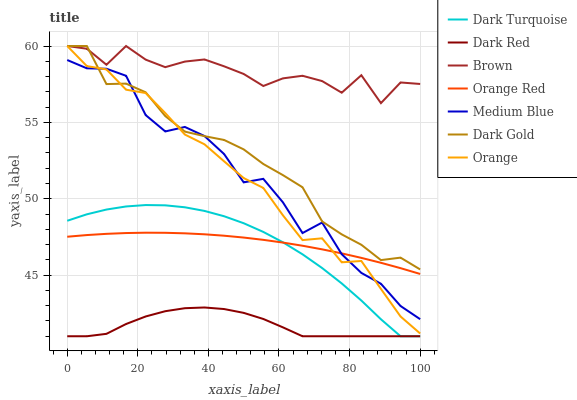Does Dark Red have the minimum area under the curve?
Answer yes or no. Yes. Does Brown have the maximum area under the curve?
Answer yes or no. Yes. Does Dark Gold have the minimum area under the curve?
Answer yes or no. No. Does Dark Gold have the maximum area under the curve?
Answer yes or no. No. Is Orange Red the smoothest?
Answer yes or no. Yes. Is Medium Blue the roughest?
Answer yes or no. Yes. Is Dark Gold the smoothest?
Answer yes or no. No. Is Dark Gold the roughest?
Answer yes or no. No. Does Dark Turquoise have the lowest value?
Answer yes or no. Yes. Does Dark Gold have the lowest value?
Answer yes or no. No. Does Orange have the highest value?
Answer yes or no. Yes. Does Dark Turquoise have the highest value?
Answer yes or no. No. Is Dark Turquoise less than Orange?
Answer yes or no. Yes. Is Medium Blue greater than Dark Turquoise?
Answer yes or no. Yes. Does Dark Red intersect Dark Turquoise?
Answer yes or no. Yes. Is Dark Red less than Dark Turquoise?
Answer yes or no. No. Is Dark Red greater than Dark Turquoise?
Answer yes or no. No. Does Dark Turquoise intersect Orange?
Answer yes or no. No. 